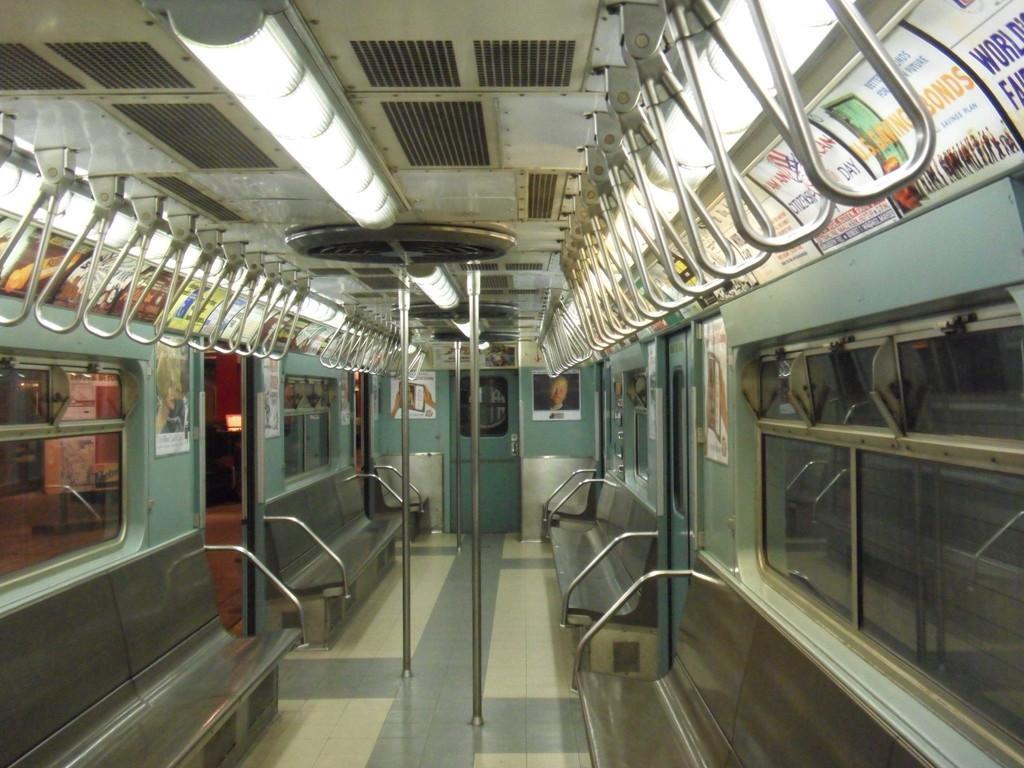Could you give a brief overview of what you see in this image? This image is inside the train where we can see seats, handles, poles, posters on the wall, ceiling lights and glass windows through which we can see the platform. 